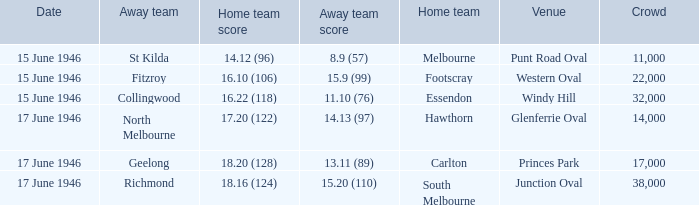On which date was a match conducted at windy hill? 15 June 1946. 